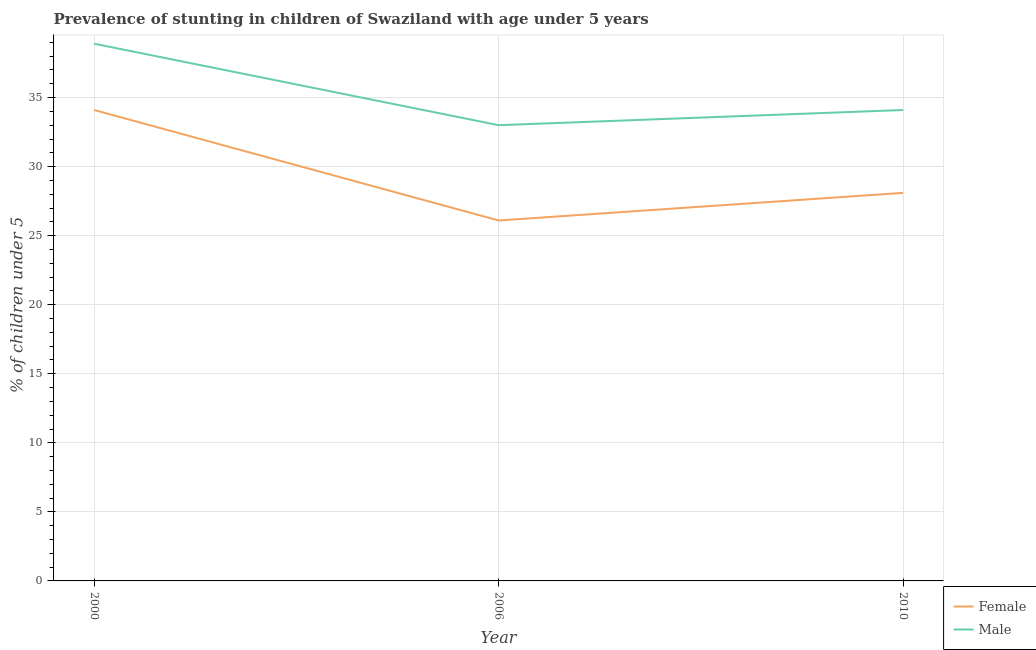How many different coloured lines are there?
Your answer should be very brief. 2. Is the number of lines equal to the number of legend labels?
Ensure brevity in your answer.  Yes. What is the percentage of stunted male children in 2000?
Give a very brief answer. 38.9. Across all years, what is the maximum percentage of stunted male children?
Offer a terse response. 38.9. Across all years, what is the minimum percentage of stunted female children?
Offer a terse response. 26.1. In which year was the percentage of stunted male children maximum?
Make the answer very short. 2000. In which year was the percentage of stunted male children minimum?
Your response must be concise. 2006. What is the total percentage of stunted male children in the graph?
Your response must be concise. 106. What is the difference between the percentage of stunted male children in 2000 and that in 2006?
Keep it short and to the point. 5.9. What is the difference between the percentage of stunted female children in 2006 and the percentage of stunted male children in 2010?
Offer a very short reply. -8. What is the average percentage of stunted female children per year?
Make the answer very short. 29.43. In the year 2010, what is the difference between the percentage of stunted male children and percentage of stunted female children?
Provide a short and direct response. 6. What is the ratio of the percentage of stunted male children in 2000 to that in 2010?
Your answer should be compact. 1.14. Is the percentage of stunted male children in 2000 less than that in 2010?
Provide a short and direct response. No. Is the difference between the percentage of stunted male children in 2000 and 2006 greater than the difference between the percentage of stunted female children in 2000 and 2006?
Give a very brief answer. No. What is the difference between the highest and the second highest percentage of stunted female children?
Offer a terse response. 6. What is the difference between the highest and the lowest percentage of stunted female children?
Provide a succinct answer. 8. In how many years, is the percentage of stunted male children greater than the average percentage of stunted male children taken over all years?
Give a very brief answer. 1. Is the sum of the percentage of stunted male children in 2000 and 2010 greater than the maximum percentage of stunted female children across all years?
Ensure brevity in your answer.  Yes. Is the percentage of stunted female children strictly greater than the percentage of stunted male children over the years?
Provide a short and direct response. No. What is the difference between two consecutive major ticks on the Y-axis?
Ensure brevity in your answer.  5. Are the values on the major ticks of Y-axis written in scientific E-notation?
Ensure brevity in your answer.  No. Does the graph contain any zero values?
Provide a succinct answer. No. What is the title of the graph?
Offer a very short reply. Prevalence of stunting in children of Swaziland with age under 5 years. Does "Start a business" appear as one of the legend labels in the graph?
Give a very brief answer. No. What is the label or title of the X-axis?
Ensure brevity in your answer.  Year. What is the label or title of the Y-axis?
Your response must be concise.  % of children under 5. What is the  % of children under 5 in Female in 2000?
Ensure brevity in your answer.  34.1. What is the  % of children under 5 in Male in 2000?
Your answer should be very brief. 38.9. What is the  % of children under 5 of Female in 2006?
Offer a very short reply. 26.1. What is the  % of children under 5 in Male in 2006?
Keep it short and to the point. 33. What is the  % of children under 5 of Female in 2010?
Make the answer very short. 28.1. What is the  % of children under 5 in Male in 2010?
Your answer should be very brief. 34.1. Across all years, what is the maximum  % of children under 5 in Female?
Give a very brief answer. 34.1. Across all years, what is the maximum  % of children under 5 of Male?
Give a very brief answer. 38.9. Across all years, what is the minimum  % of children under 5 of Female?
Offer a very short reply. 26.1. Across all years, what is the minimum  % of children under 5 of Male?
Your answer should be compact. 33. What is the total  % of children under 5 of Female in the graph?
Provide a succinct answer. 88.3. What is the total  % of children under 5 of Male in the graph?
Your answer should be very brief. 106. What is the difference between the  % of children under 5 in Female in 2000 and that in 2006?
Your answer should be very brief. 8. What is the difference between the  % of children under 5 of Male in 2000 and that in 2006?
Provide a short and direct response. 5.9. What is the difference between the  % of children under 5 of Female in 2006 and that in 2010?
Provide a succinct answer. -2. What is the difference between the  % of children under 5 in Male in 2006 and that in 2010?
Provide a short and direct response. -1.1. What is the average  % of children under 5 of Female per year?
Offer a very short reply. 29.43. What is the average  % of children under 5 of Male per year?
Your answer should be very brief. 35.33. In the year 2000, what is the difference between the  % of children under 5 of Female and  % of children under 5 of Male?
Provide a short and direct response. -4.8. What is the ratio of the  % of children under 5 in Female in 2000 to that in 2006?
Provide a short and direct response. 1.31. What is the ratio of the  % of children under 5 of Male in 2000 to that in 2006?
Make the answer very short. 1.18. What is the ratio of the  % of children under 5 in Female in 2000 to that in 2010?
Your response must be concise. 1.21. What is the ratio of the  % of children under 5 in Male in 2000 to that in 2010?
Offer a terse response. 1.14. What is the ratio of the  % of children under 5 of Female in 2006 to that in 2010?
Provide a short and direct response. 0.93. What is the ratio of the  % of children under 5 of Male in 2006 to that in 2010?
Keep it short and to the point. 0.97. What is the difference between the highest and the lowest  % of children under 5 of Female?
Your response must be concise. 8. What is the difference between the highest and the lowest  % of children under 5 of Male?
Your response must be concise. 5.9. 